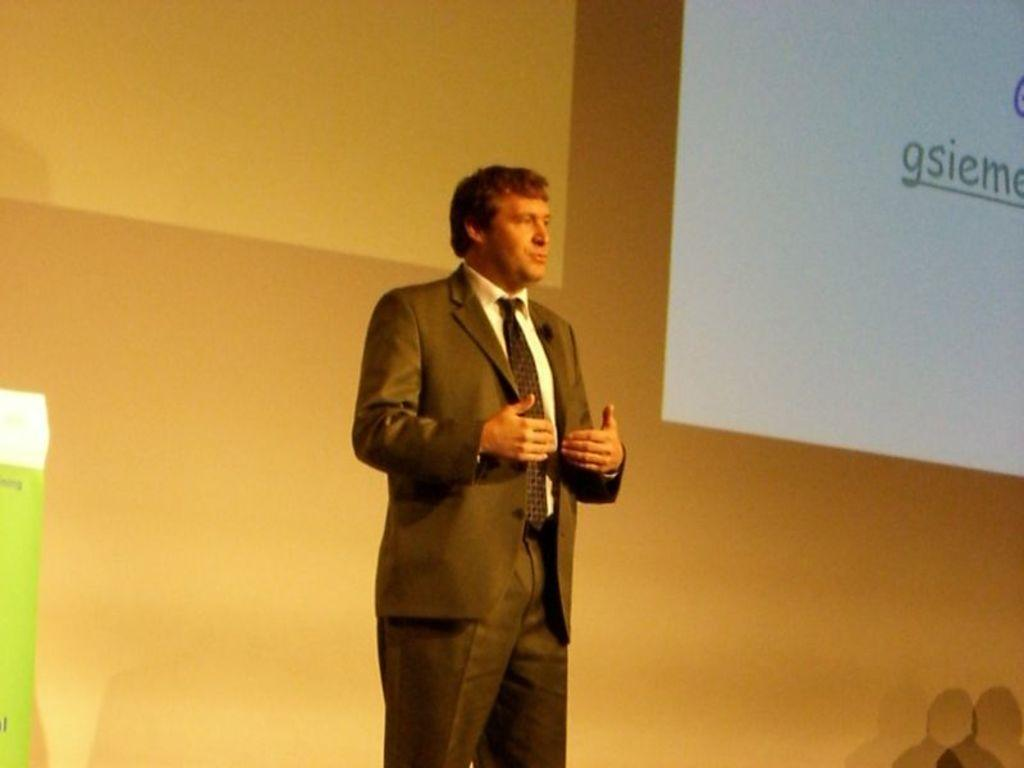What is the main subject of the image? There is a man standing in the image. What can be observed about the man's appearance? The man is wearing clothes. What is the purpose of the projected screen in the image? The projected screen is likely used for displaying information or visuals. What type of architectural feature is present in the image? There is a wall in the image. What type of cream is being used to build the structure in the image? There is no structure or cream present in the image; it features a man standing, a projected screen, and a wall. 